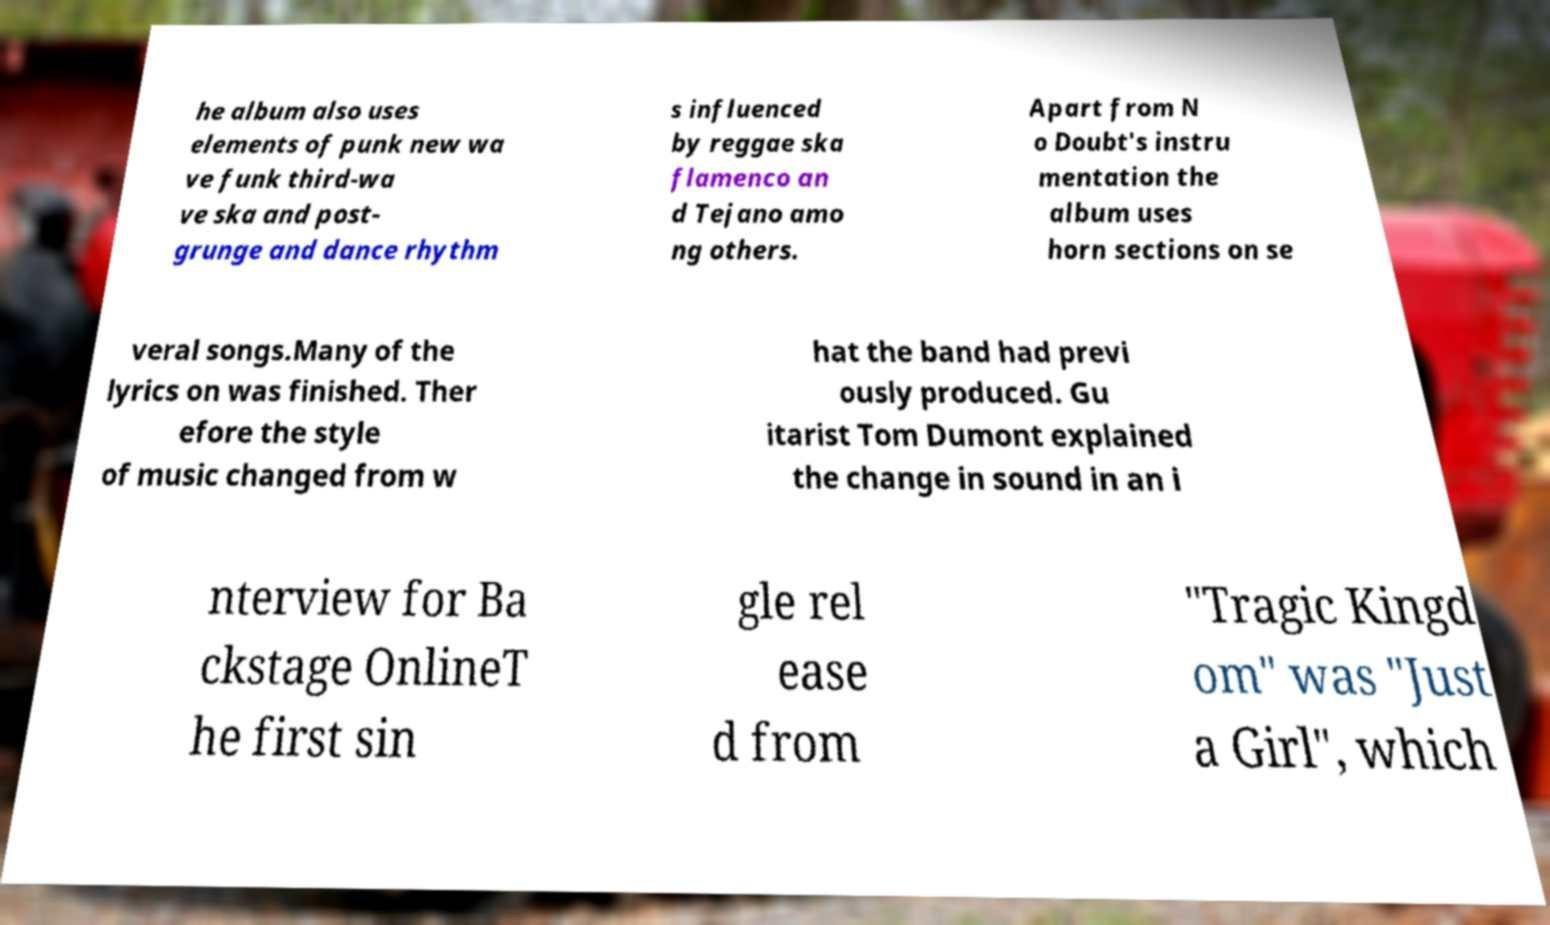Please read and relay the text visible in this image. What does it say? he album also uses elements of punk new wa ve funk third-wa ve ska and post- grunge and dance rhythm s influenced by reggae ska flamenco an d Tejano amo ng others. Apart from N o Doubt's instru mentation the album uses horn sections on se veral songs.Many of the lyrics on was finished. Ther efore the style of music changed from w hat the band had previ ously produced. Gu itarist Tom Dumont explained the change in sound in an i nterview for Ba ckstage OnlineT he first sin gle rel ease d from "Tragic Kingd om" was "Just a Girl", which 